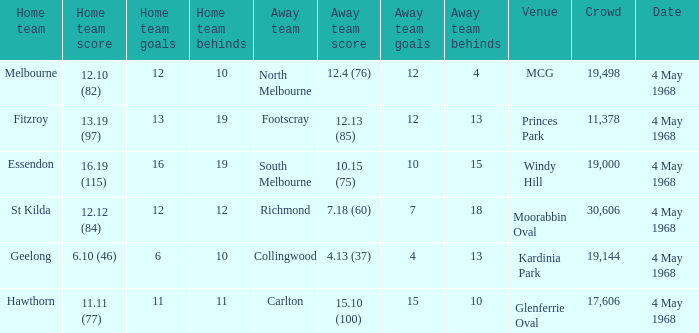What home team played at MCG? North Melbourne. 